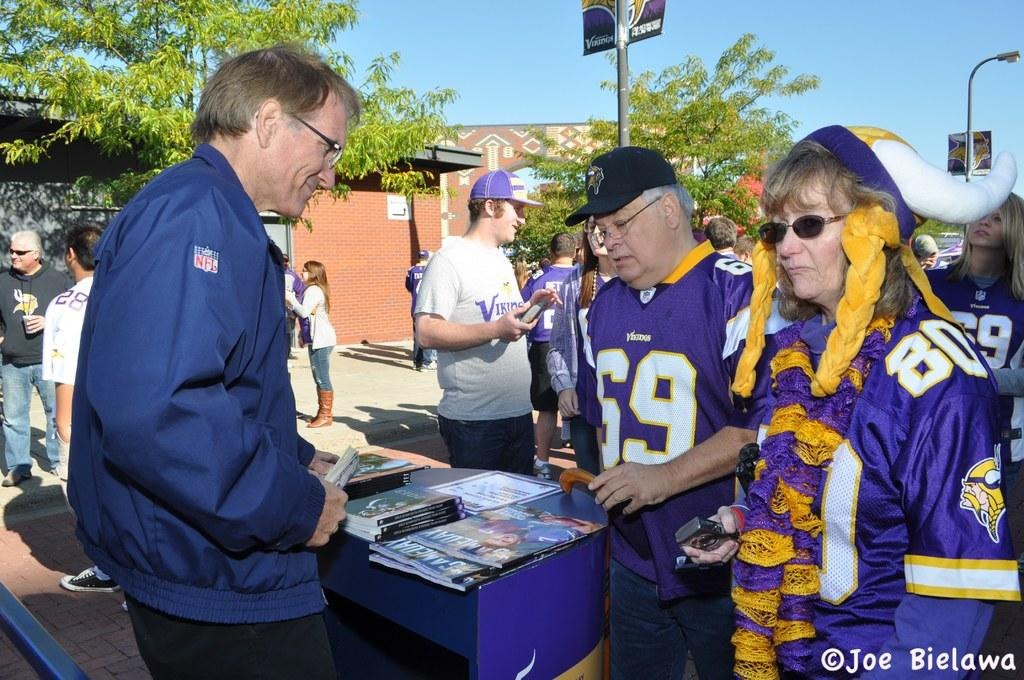<image>
Share a concise interpretation of the image provided. Two Minnesota Vikings fans are buying Gameday programs from a vendor. 